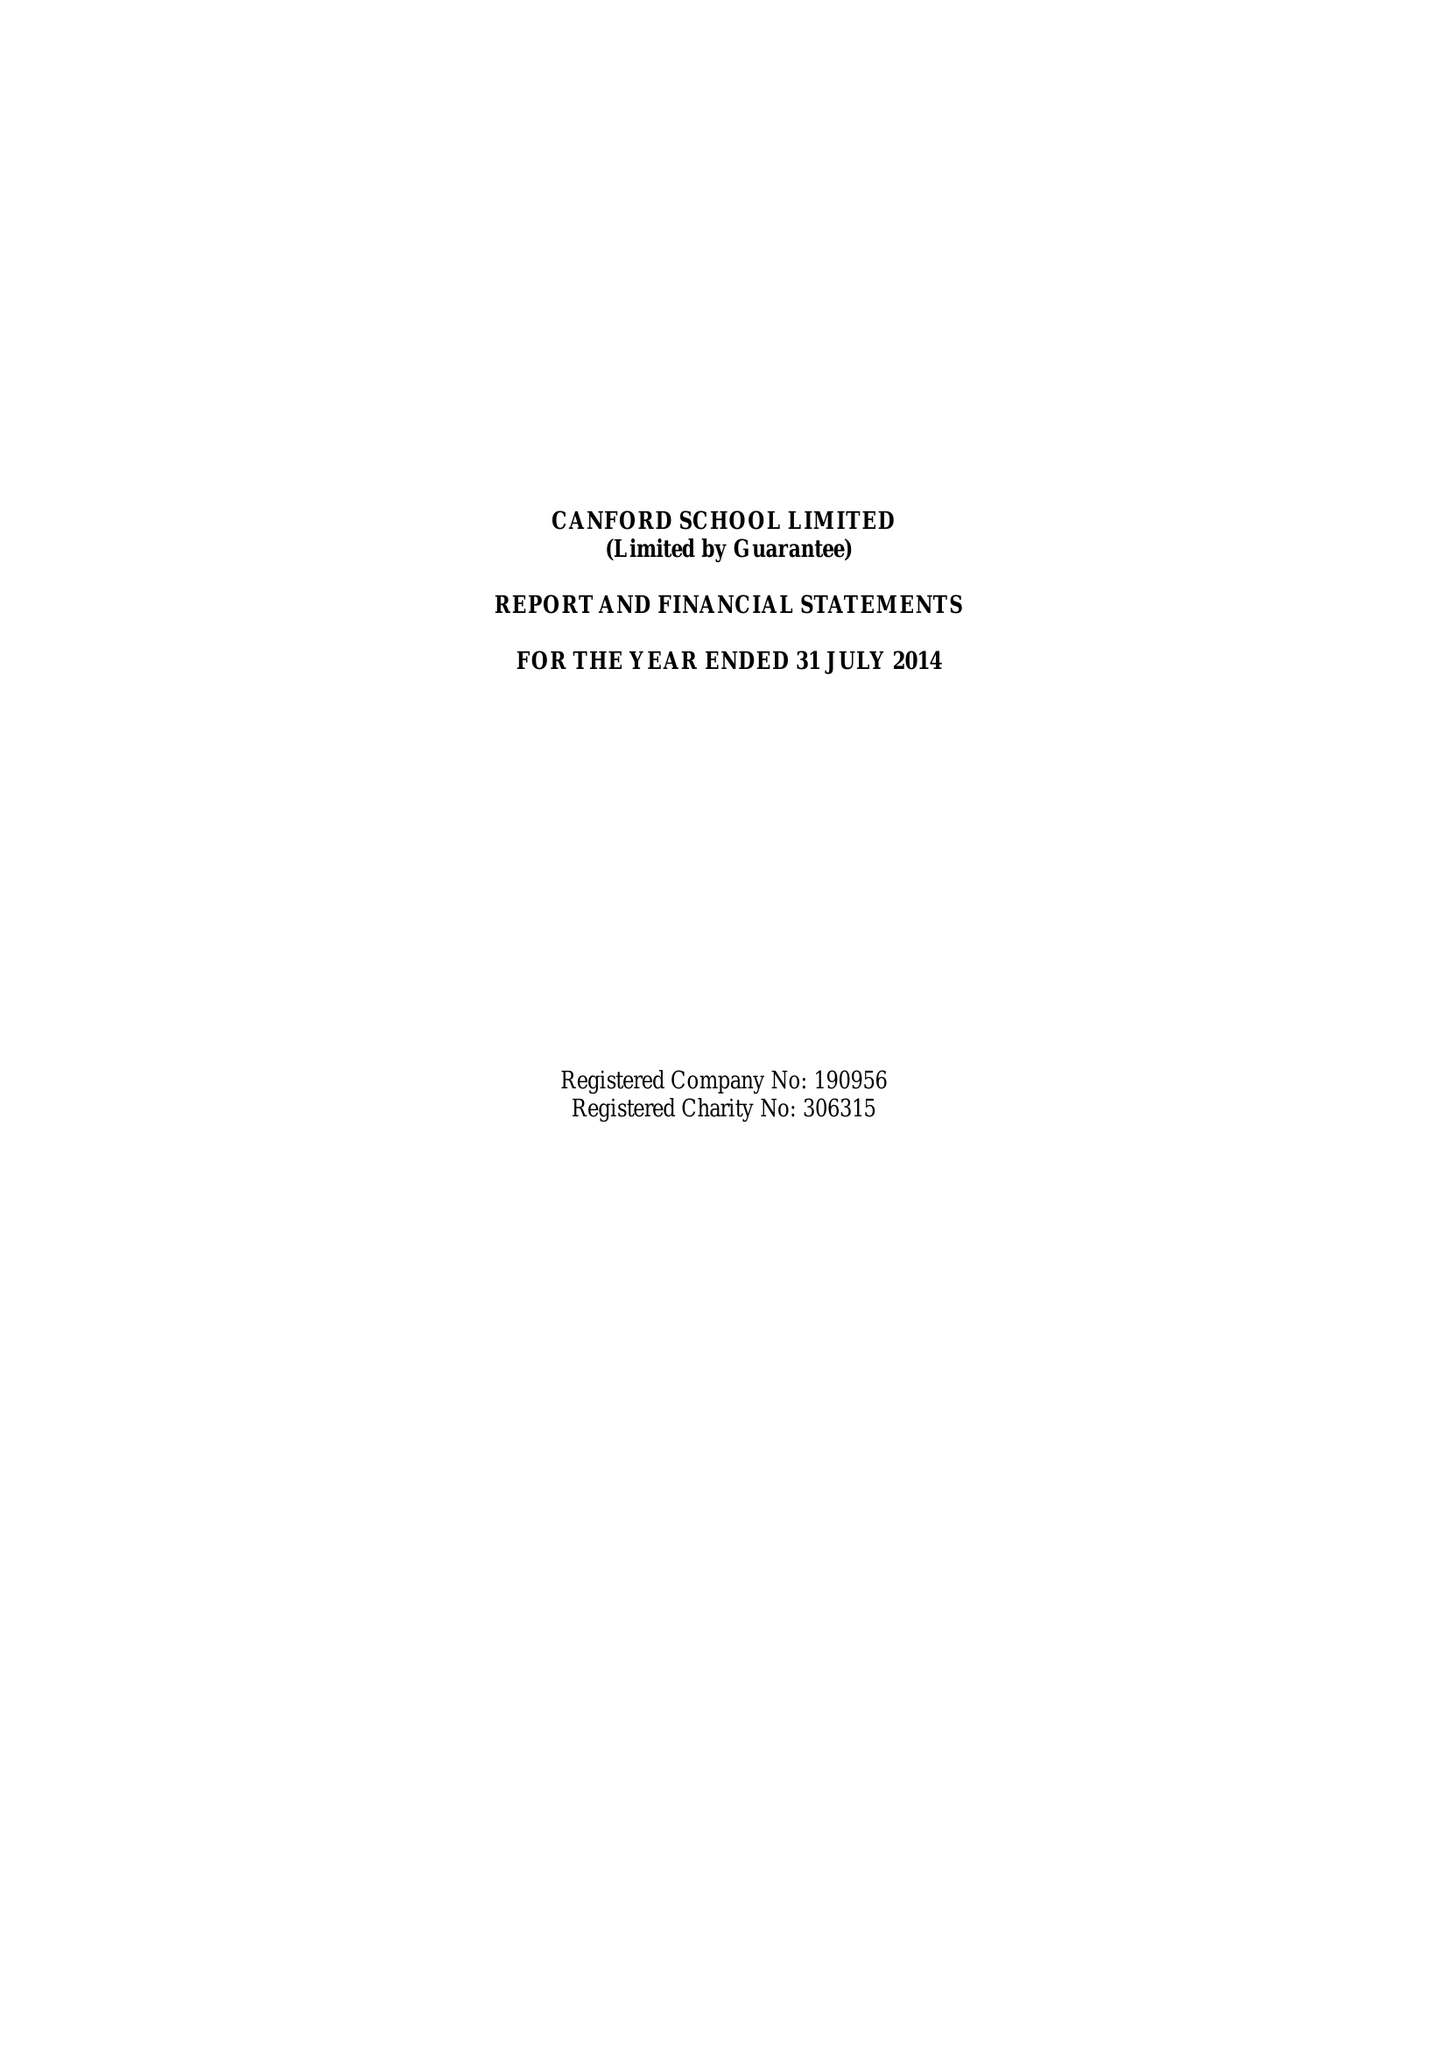What is the value for the income_annually_in_british_pounds?
Answer the question using a single word or phrase. 18192947.00 